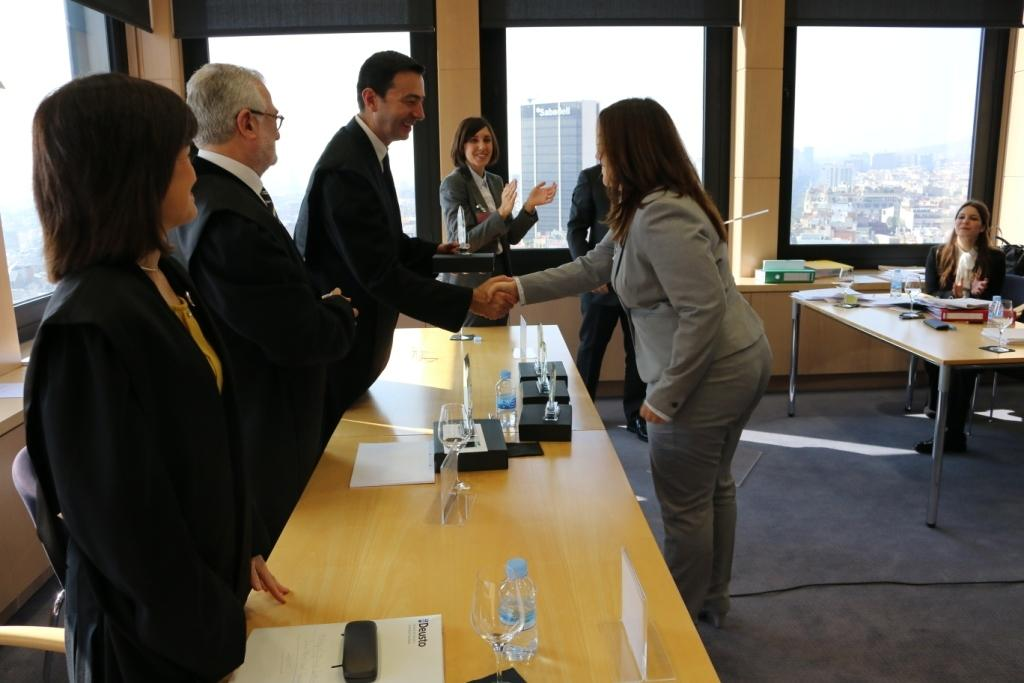How many people are in the image? There is a group of people in the image. Can you describe an interaction between two people in the image? One man is shaking hands with one woman in the image. What type of structures can be seen in the image? There are buildings in the image. What architectural feature is visible in the image? There are windows in the image. What objects can be seen in the background of the image? Tables and water bottles are present in the background of the image. What songs are being sung by the sisters in the image? There are no sisters or songs present in the image. What impulse caused the people to gather in the image? The image does not provide information about the reason or impulse for the gathering of people. 